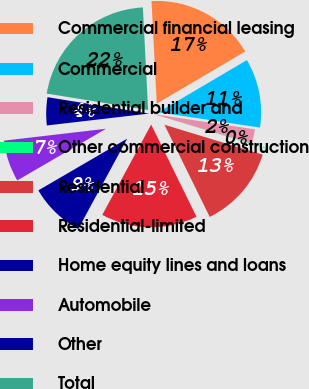<chart> <loc_0><loc_0><loc_500><loc_500><pie_chart><fcel>Commercial financial leasing<fcel>Commercial<fcel>Residential builder and<fcel>Other commercial construction<fcel>Residential<fcel>Residential-limited<fcel>Home equity lines and loans<fcel>Automobile<fcel>Other<fcel>Total<nl><fcel>17.33%<fcel>10.86%<fcel>2.24%<fcel>0.09%<fcel>13.02%<fcel>15.17%<fcel>8.71%<fcel>6.55%<fcel>4.4%<fcel>21.63%<nl></chart> 